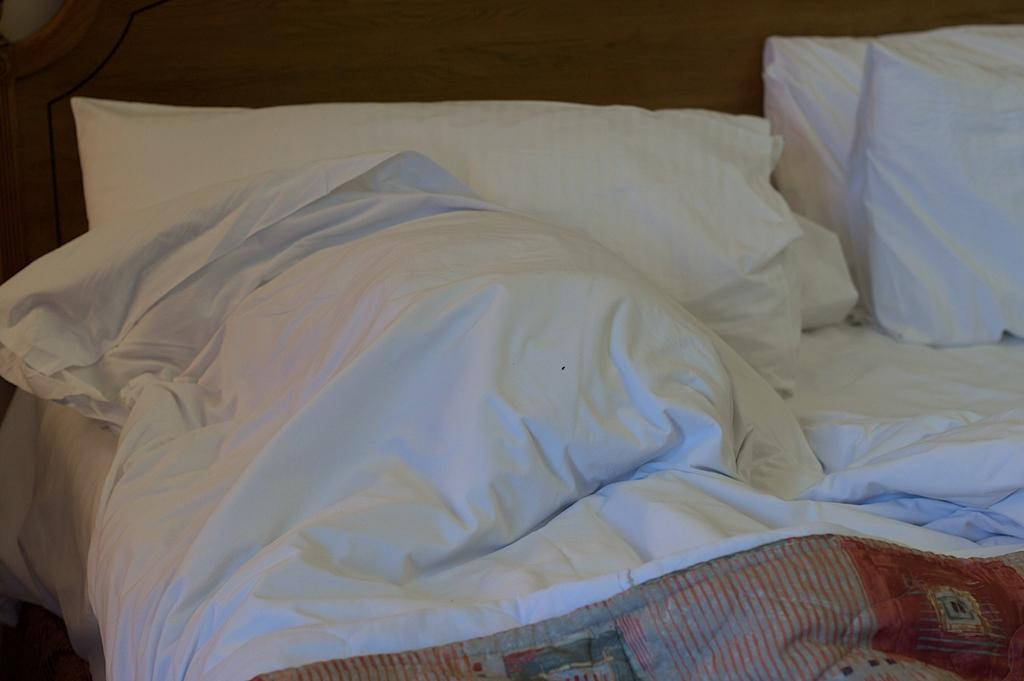What type of furniture is present in the image? There is a bed in the image. What color is the bed? The bed is white. What accessories are on the bed? There are pillows and a blanket on the bed. Is there a mask on the bed in the image? There is no mask present on the bed in the image. 